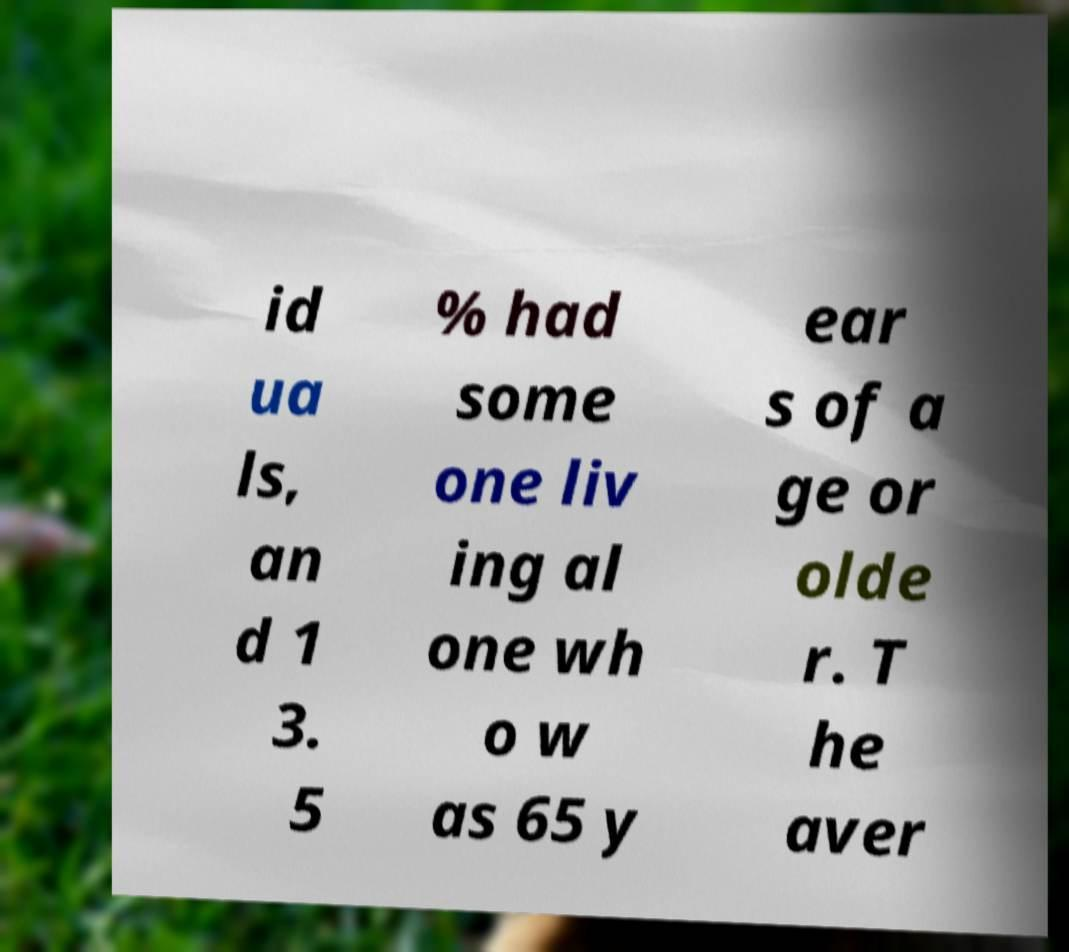Can you accurately transcribe the text from the provided image for me? id ua ls, an d 1 3. 5 % had some one liv ing al one wh o w as 65 y ear s of a ge or olde r. T he aver 